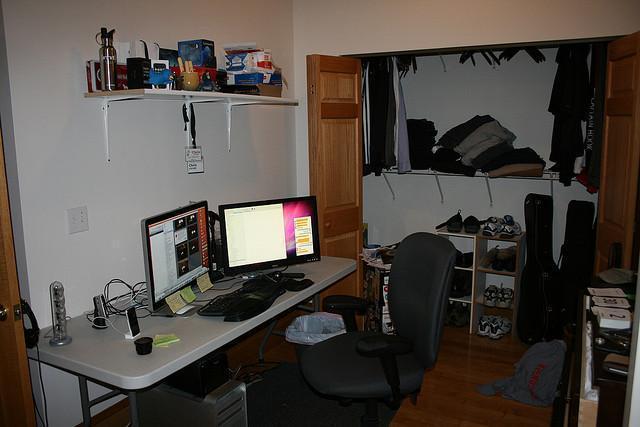How many monitors are on the desk?
Give a very brief answer. 2. How many chairs are there?
Give a very brief answer. 1. How many tvs are there?
Give a very brief answer. 2. 